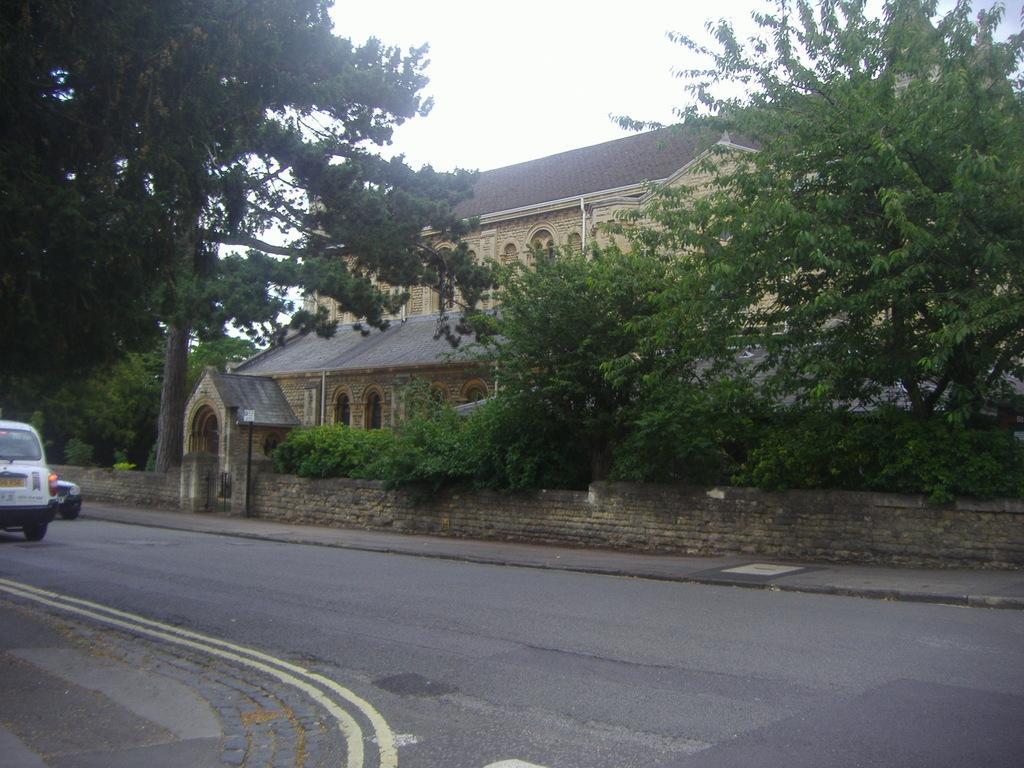How would you summarize this image in a sentence or two? To the bottom of the image there is a road. To the left side corner on the road there is a car. Behind the road there is a footpath. Behind the footpath there is a wall with gate. Behind the gate there is a building with roofs and windows. To the top of the image there is a sky. 